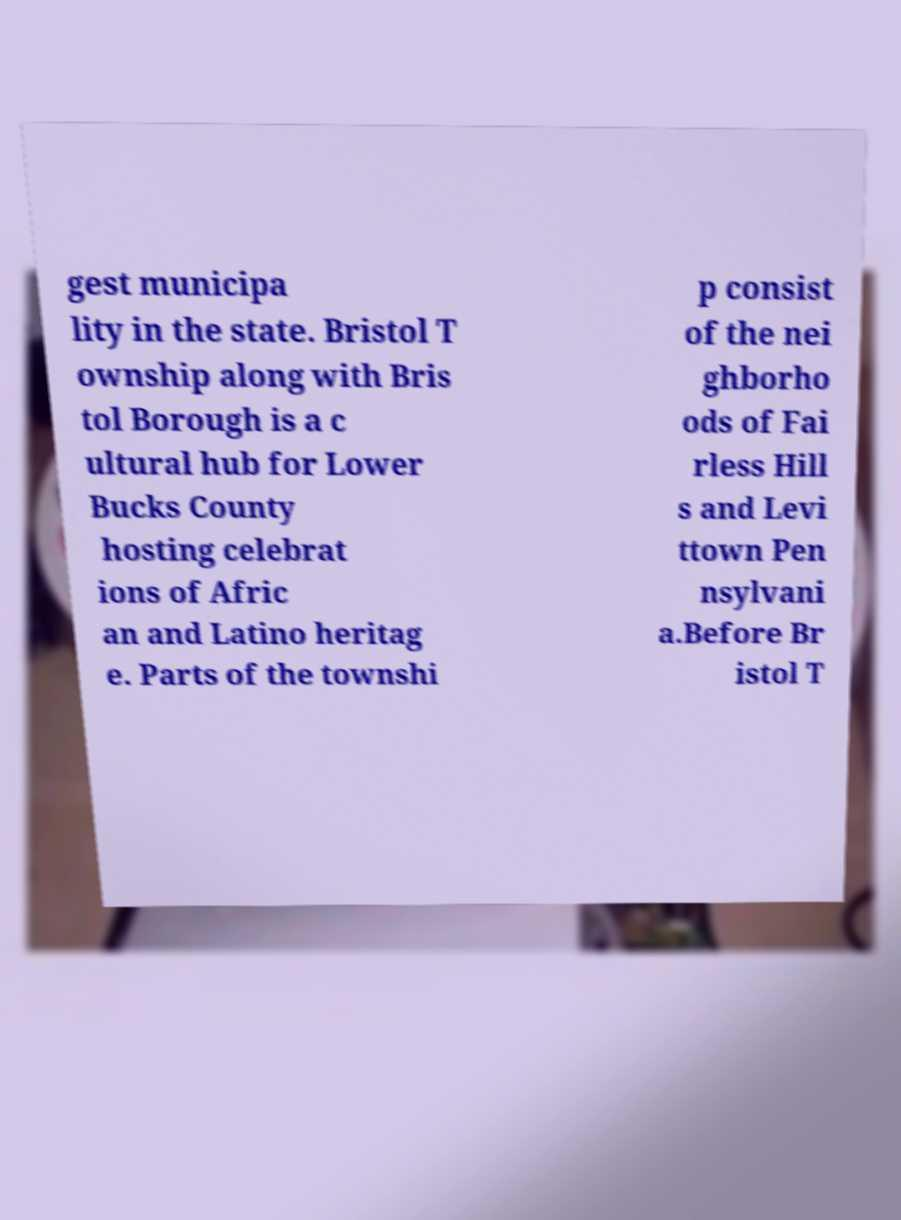What messages or text are displayed in this image? I need them in a readable, typed format. gest municipa lity in the state. Bristol T ownship along with Bris tol Borough is a c ultural hub for Lower Bucks County hosting celebrat ions of Afric an and Latino heritag e. Parts of the townshi p consist of the nei ghborho ods of Fai rless Hill s and Levi ttown Pen nsylvani a.Before Br istol T 